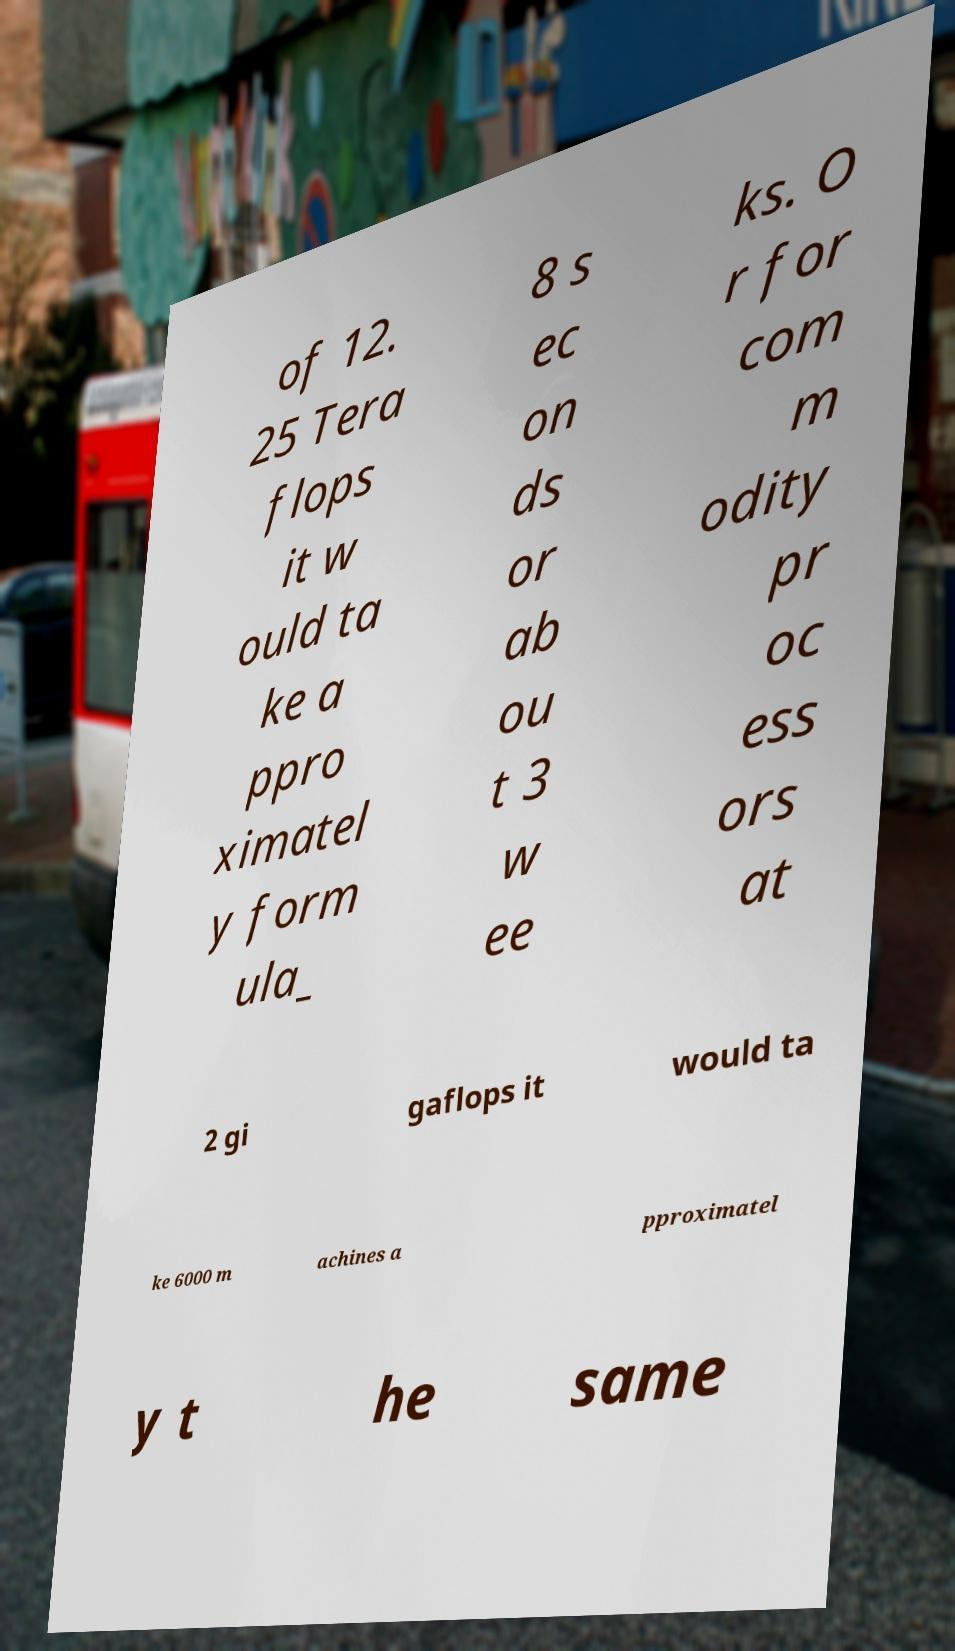For documentation purposes, I need the text within this image transcribed. Could you provide that? of 12. 25 Tera flops it w ould ta ke a ppro ximatel y form ula_ 8 s ec on ds or ab ou t 3 w ee ks. O r for com m odity pr oc ess ors at 2 gi gaflops it would ta ke 6000 m achines a pproximatel y t he same 